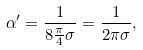<formula> <loc_0><loc_0><loc_500><loc_500>\alpha ^ { \prime } = \frac { 1 } { 8 \frac { \pi } { 4 } \sigma } = \frac { 1 } { 2 \pi \sigma } ,</formula> 